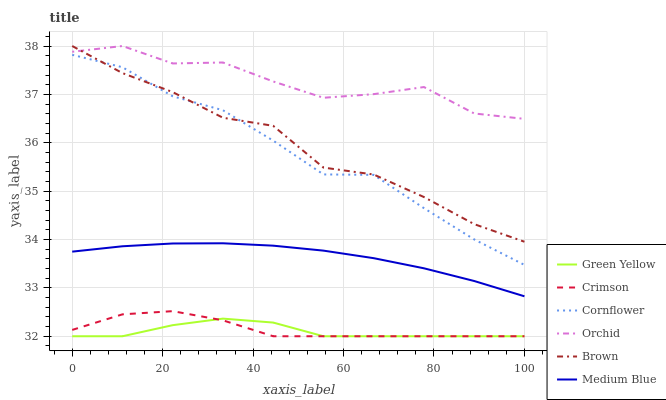Does Green Yellow have the minimum area under the curve?
Answer yes or no. Yes. Does Orchid have the maximum area under the curve?
Answer yes or no. Yes. Does Brown have the minimum area under the curve?
Answer yes or no. No. Does Brown have the maximum area under the curve?
Answer yes or no. No. Is Medium Blue the smoothest?
Answer yes or no. Yes. Is Orchid the roughest?
Answer yes or no. Yes. Is Brown the smoothest?
Answer yes or no. No. Is Brown the roughest?
Answer yes or no. No. Does Crimson have the lowest value?
Answer yes or no. Yes. Does Brown have the lowest value?
Answer yes or no. No. Does Orchid have the highest value?
Answer yes or no. Yes. Does Medium Blue have the highest value?
Answer yes or no. No. Is Green Yellow less than Orchid?
Answer yes or no. Yes. Is Brown greater than Green Yellow?
Answer yes or no. Yes. Does Cornflower intersect Brown?
Answer yes or no. Yes. Is Cornflower less than Brown?
Answer yes or no. No. Is Cornflower greater than Brown?
Answer yes or no. No. Does Green Yellow intersect Orchid?
Answer yes or no. No. 